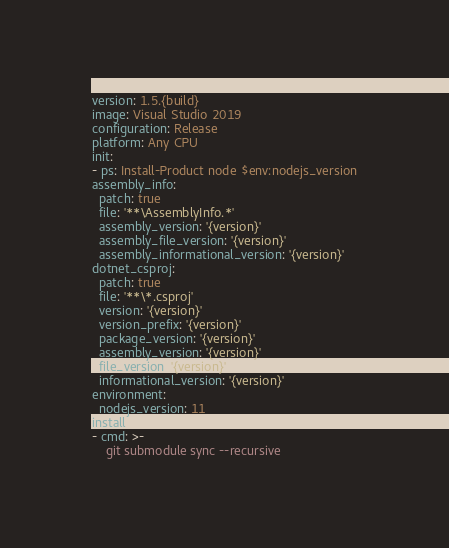<code> <loc_0><loc_0><loc_500><loc_500><_YAML_>version: 1.5.{build}
image: Visual Studio 2019
configuration: Release
platform: Any CPU
init:
- ps: Install-Product node $env:nodejs_version
assembly_info:
  patch: true
  file: '**\AssemblyInfo.*'
  assembly_version: '{version}'
  assembly_file_version: '{version}'
  assembly_informational_version: '{version}'
dotnet_csproj:
  patch: true
  file: '**\*.csproj'
  version: '{version}'
  version_prefix: '{version}'
  package_version: '{version}'
  assembly_version: '{version}'
  file_version: '{version}'
  informational_version: '{version}'
environment:
  nodejs_version: 11
install:
- cmd: >-
    git submodule sync --recursive
</code> 